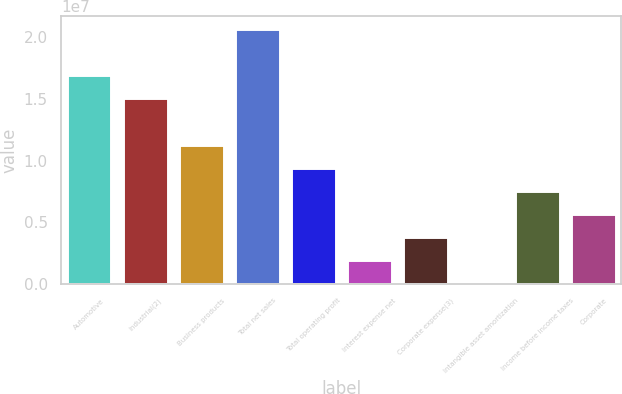Convert chart. <chart><loc_0><loc_0><loc_500><loc_500><bar_chart><fcel>Automotive<fcel>Industrial(2)<fcel>Business products<fcel>Total net sales<fcel>Total operating profit<fcel>Interest expense net<fcel>Corporate expense(3)<fcel>Intangible asset amortization<fcel>Income before income taxes<fcel>Corporate<nl><fcel>1.68705e+07<fcel>1.50059e+07<fcel>1.12766e+07<fcel>2.05997e+07<fcel>9.41202e+06<fcel>1.95358e+06<fcel>3.81819e+06<fcel>88972<fcel>7.54741e+06<fcel>5.6828e+06<nl></chart> 